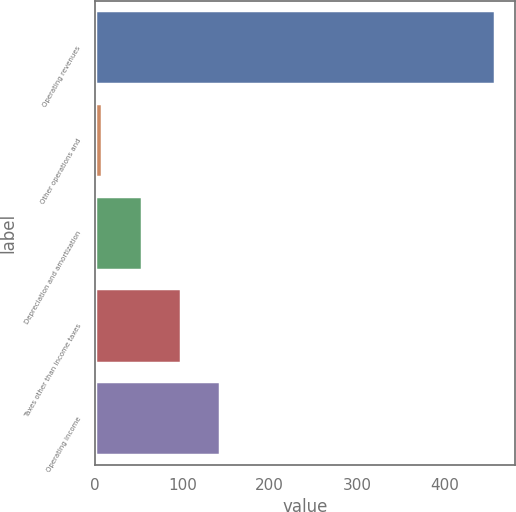Convert chart to OTSL. <chart><loc_0><loc_0><loc_500><loc_500><bar_chart><fcel>Operating revenues<fcel>Other operations and<fcel>Depreciation and amortization<fcel>Taxes other than income taxes<fcel>Operating income<nl><fcel>458<fcel>8<fcel>53<fcel>98<fcel>143<nl></chart> 